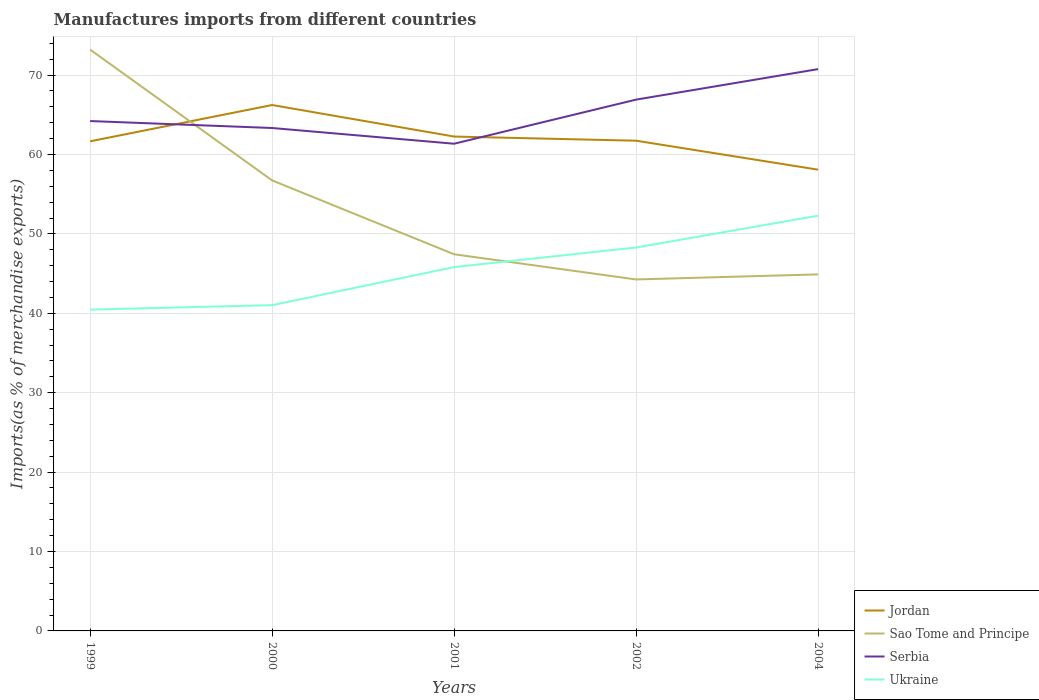How many different coloured lines are there?
Your response must be concise. 4. Does the line corresponding to Ukraine intersect with the line corresponding to Sao Tome and Principe?
Ensure brevity in your answer.  Yes. Across all years, what is the maximum percentage of imports to different countries in Jordan?
Make the answer very short. 58.09. What is the total percentage of imports to different countries in Sao Tome and Principe in the graph?
Provide a succinct answer. 11.83. What is the difference between the highest and the second highest percentage of imports to different countries in Sao Tome and Principe?
Ensure brevity in your answer.  28.95. How many lines are there?
Make the answer very short. 4. How many years are there in the graph?
Ensure brevity in your answer.  5. Does the graph contain any zero values?
Offer a terse response. No. Where does the legend appear in the graph?
Keep it short and to the point. Bottom right. How many legend labels are there?
Give a very brief answer. 4. What is the title of the graph?
Offer a terse response. Manufactures imports from different countries. Does "Cayman Islands" appear as one of the legend labels in the graph?
Give a very brief answer. No. What is the label or title of the Y-axis?
Keep it short and to the point. Imports(as % of merchandise exports). What is the Imports(as % of merchandise exports) of Jordan in 1999?
Your answer should be compact. 61.66. What is the Imports(as % of merchandise exports) of Sao Tome and Principe in 1999?
Your answer should be very brief. 73.21. What is the Imports(as % of merchandise exports) of Serbia in 1999?
Ensure brevity in your answer.  64.21. What is the Imports(as % of merchandise exports) of Ukraine in 1999?
Your answer should be compact. 40.46. What is the Imports(as % of merchandise exports) of Jordan in 2000?
Provide a succinct answer. 66.23. What is the Imports(as % of merchandise exports) in Sao Tome and Principe in 2000?
Offer a very short reply. 56.74. What is the Imports(as % of merchandise exports) in Serbia in 2000?
Offer a terse response. 63.34. What is the Imports(as % of merchandise exports) in Ukraine in 2000?
Your answer should be compact. 41.03. What is the Imports(as % of merchandise exports) of Jordan in 2001?
Your answer should be compact. 62.26. What is the Imports(as % of merchandise exports) of Sao Tome and Principe in 2001?
Your answer should be compact. 47.44. What is the Imports(as % of merchandise exports) of Serbia in 2001?
Offer a very short reply. 61.36. What is the Imports(as % of merchandise exports) in Ukraine in 2001?
Your answer should be very brief. 45.82. What is the Imports(as % of merchandise exports) of Jordan in 2002?
Your answer should be very brief. 61.74. What is the Imports(as % of merchandise exports) in Sao Tome and Principe in 2002?
Offer a terse response. 44.26. What is the Imports(as % of merchandise exports) in Serbia in 2002?
Give a very brief answer. 66.91. What is the Imports(as % of merchandise exports) in Ukraine in 2002?
Give a very brief answer. 48.29. What is the Imports(as % of merchandise exports) in Jordan in 2004?
Offer a very short reply. 58.09. What is the Imports(as % of merchandise exports) in Sao Tome and Principe in 2004?
Offer a very short reply. 44.9. What is the Imports(as % of merchandise exports) of Serbia in 2004?
Provide a succinct answer. 70.75. What is the Imports(as % of merchandise exports) of Ukraine in 2004?
Your response must be concise. 52.3. Across all years, what is the maximum Imports(as % of merchandise exports) of Jordan?
Your answer should be very brief. 66.23. Across all years, what is the maximum Imports(as % of merchandise exports) in Sao Tome and Principe?
Give a very brief answer. 73.21. Across all years, what is the maximum Imports(as % of merchandise exports) in Serbia?
Ensure brevity in your answer.  70.75. Across all years, what is the maximum Imports(as % of merchandise exports) in Ukraine?
Your answer should be very brief. 52.3. Across all years, what is the minimum Imports(as % of merchandise exports) in Jordan?
Ensure brevity in your answer.  58.09. Across all years, what is the minimum Imports(as % of merchandise exports) in Sao Tome and Principe?
Your response must be concise. 44.26. Across all years, what is the minimum Imports(as % of merchandise exports) in Serbia?
Provide a short and direct response. 61.36. Across all years, what is the minimum Imports(as % of merchandise exports) in Ukraine?
Provide a short and direct response. 40.46. What is the total Imports(as % of merchandise exports) of Jordan in the graph?
Your answer should be very brief. 309.98. What is the total Imports(as % of merchandise exports) of Sao Tome and Principe in the graph?
Offer a terse response. 266.55. What is the total Imports(as % of merchandise exports) of Serbia in the graph?
Your response must be concise. 326.57. What is the total Imports(as % of merchandise exports) of Ukraine in the graph?
Provide a succinct answer. 227.9. What is the difference between the Imports(as % of merchandise exports) in Jordan in 1999 and that in 2000?
Provide a short and direct response. -4.57. What is the difference between the Imports(as % of merchandise exports) in Sao Tome and Principe in 1999 and that in 2000?
Your answer should be compact. 16.48. What is the difference between the Imports(as % of merchandise exports) of Serbia in 1999 and that in 2000?
Give a very brief answer. 0.88. What is the difference between the Imports(as % of merchandise exports) in Ukraine in 1999 and that in 2000?
Offer a terse response. -0.56. What is the difference between the Imports(as % of merchandise exports) of Jordan in 1999 and that in 2001?
Offer a terse response. -0.6. What is the difference between the Imports(as % of merchandise exports) of Sao Tome and Principe in 1999 and that in 2001?
Keep it short and to the point. 25.78. What is the difference between the Imports(as % of merchandise exports) of Serbia in 1999 and that in 2001?
Provide a short and direct response. 2.85. What is the difference between the Imports(as % of merchandise exports) of Ukraine in 1999 and that in 2001?
Your answer should be compact. -5.36. What is the difference between the Imports(as % of merchandise exports) of Jordan in 1999 and that in 2002?
Make the answer very short. -0.08. What is the difference between the Imports(as % of merchandise exports) of Sao Tome and Principe in 1999 and that in 2002?
Offer a very short reply. 28.95. What is the difference between the Imports(as % of merchandise exports) of Serbia in 1999 and that in 2002?
Your answer should be compact. -2.7. What is the difference between the Imports(as % of merchandise exports) of Ukraine in 1999 and that in 2002?
Your answer should be very brief. -7.82. What is the difference between the Imports(as % of merchandise exports) in Jordan in 1999 and that in 2004?
Offer a very short reply. 3.57. What is the difference between the Imports(as % of merchandise exports) of Sao Tome and Principe in 1999 and that in 2004?
Your response must be concise. 28.31. What is the difference between the Imports(as % of merchandise exports) of Serbia in 1999 and that in 2004?
Give a very brief answer. -6.54. What is the difference between the Imports(as % of merchandise exports) in Ukraine in 1999 and that in 2004?
Offer a terse response. -11.83. What is the difference between the Imports(as % of merchandise exports) in Jordan in 2000 and that in 2001?
Your response must be concise. 3.97. What is the difference between the Imports(as % of merchandise exports) in Sao Tome and Principe in 2000 and that in 2001?
Keep it short and to the point. 9.3. What is the difference between the Imports(as % of merchandise exports) in Serbia in 2000 and that in 2001?
Provide a succinct answer. 1.98. What is the difference between the Imports(as % of merchandise exports) of Ukraine in 2000 and that in 2001?
Give a very brief answer. -4.8. What is the difference between the Imports(as % of merchandise exports) of Jordan in 2000 and that in 2002?
Your answer should be compact. 4.49. What is the difference between the Imports(as % of merchandise exports) in Sao Tome and Principe in 2000 and that in 2002?
Make the answer very short. 12.47. What is the difference between the Imports(as % of merchandise exports) of Serbia in 2000 and that in 2002?
Offer a very short reply. -3.58. What is the difference between the Imports(as % of merchandise exports) of Ukraine in 2000 and that in 2002?
Provide a short and direct response. -7.26. What is the difference between the Imports(as % of merchandise exports) in Jordan in 2000 and that in 2004?
Offer a terse response. 8.14. What is the difference between the Imports(as % of merchandise exports) in Sao Tome and Principe in 2000 and that in 2004?
Keep it short and to the point. 11.83. What is the difference between the Imports(as % of merchandise exports) in Serbia in 2000 and that in 2004?
Your response must be concise. -7.42. What is the difference between the Imports(as % of merchandise exports) of Ukraine in 2000 and that in 2004?
Ensure brevity in your answer.  -11.27. What is the difference between the Imports(as % of merchandise exports) of Jordan in 2001 and that in 2002?
Your response must be concise. 0.52. What is the difference between the Imports(as % of merchandise exports) in Sao Tome and Principe in 2001 and that in 2002?
Offer a very short reply. 3.17. What is the difference between the Imports(as % of merchandise exports) of Serbia in 2001 and that in 2002?
Make the answer very short. -5.55. What is the difference between the Imports(as % of merchandise exports) in Ukraine in 2001 and that in 2002?
Your response must be concise. -2.47. What is the difference between the Imports(as % of merchandise exports) in Jordan in 2001 and that in 2004?
Keep it short and to the point. 4.17. What is the difference between the Imports(as % of merchandise exports) in Sao Tome and Principe in 2001 and that in 2004?
Offer a very short reply. 2.53. What is the difference between the Imports(as % of merchandise exports) in Serbia in 2001 and that in 2004?
Keep it short and to the point. -9.4. What is the difference between the Imports(as % of merchandise exports) in Ukraine in 2001 and that in 2004?
Your answer should be very brief. -6.47. What is the difference between the Imports(as % of merchandise exports) of Jordan in 2002 and that in 2004?
Keep it short and to the point. 3.65. What is the difference between the Imports(as % of merchandise exports) of Sao Tome and Principe in 2002 and that in 2004?
Offer a terse response. -0.64. What is the difference between the Imports(as % of merchandise exports) in Serbia in 2002 and that in 2004?
Your response must be concise. -3.84. What is the difference between the Imports(as % of merchandise exports) of Ukraine in 2002 and that in 2004?
Give a very brief answer. -4.01. What is the difference between the Imports(as % of merchandise exports) of Jordan in 1999 and the Imports(as % of merchandise exports) of Sao Tome and Principe in 2000?
Ensure brevity in your answer.  4.92. What is the difference between the Imports(as % of merchandise exports) of Jordan in 1999 and the Imports(as % of merchandise exports) of Serbia in 2000?
Keep it short and to the point. -1.68. What is the difference between the Imports(as % of merchandise exports) in Jordan in 1999 and the Imports(as % of merchandise exports) in Ukraine in 2000?
Provide a short and direct response. 20.63. What is the difference between the Imports(as % of merchandise exports) of Sao Tome and Principe in 1999 and the Imports(as % of merchandise exports) of Serbia in 2000?
Your answer should be compact. 9.88. What is the difference between the Imports(as % of merchandise exports) in Sao Tome and Principe in 1999 and the Imports(as % of merchandise exports) in Ukraine in 2000?
Offer a terse response. 32.19. What is the difference between the Imports(as % of merchandise exports) of Serbia in 1999 and the Imports(as % of merchandise exports) of Ukraine in 2000?
Provide a short and direct response. 23.18. What is the difference between the Imports(as % of merchandise exports) of Jordan in 1999 and the Imports(as % of merchandise exports) of Sao Tome and Principe in 2001?
Your response must be concise. 14.23. What is the difference between the Imports(as % of merchandise exports) in Jordan in 1999 and the Imports(as % of merchandise exports) in Serbia in 2001?
Provide a short and direct response. 0.3. What is the difference between the Imports(as % of merchandise exports) in Jordan in 1999 and the Imports(as % of merchandise exports) in Ukraine in 2001?
Your answer should be compact. 15.84. What is the difference between the Imports(as % of merchandise exports) in Sao Tome and Principe in 1999 and the Imports(as % of merchandise exports) in Serbia in 2001?
Make the answer very short. 11.86. What is the difference between the Imports(as % of merchandise exports) of Sao Tome and Principe in 1999 and the Imports(as % of merchandise exports) of Ukraine in 2001?
Offer a very short reply. 27.39. What is the difference between the Imports(as % of merchandise exports) in Serbia in 1999 and the Imports(as % of merchandise exports) in Ukraine in 2001?
Your answer should be very brief. 18.39. What is the difference between the Imports(as % of merchandise exports) of Jordan in 1999 and the Imports(as % of merchandise exports) of Sao Tome and Principe in 2002?
Offer a terse response. 17.4. What is the difference between the Imports(as % of merchandise exports) of Jordan in 1999 and the Imports(as % of merchandise exports) of Serbia in 2002?
Your response must be concise. -5.25. What is the difference between the Imports(as % of merchandise exports) in Jordan in 1999 and the Imports(as % of merchandise exports) in Ukraine in 2002?
Keep it short and to the point. 13.37. What is the difference between the Imports(as % of merchandise exports) in Sao Tome and Principe in 1999 and the Imports(as % of merchandise exports) in Serbia in 2002?
Make the answer very short. 6.3. What is the difference between the Imports(as % of merchandise exports) of Sao Tome and Principe in 1999 and the Imports(as % of merchandise exports) of Ukraine in 2002?
Your response must be concise. 24.93. What is the difference between the Imports(as % of merchandise exports) in Serbia in 1999 and the Imports(as % of merchandise exports) in Ukraine in 2002?
Your answer should be very brief. 15.92. What is the difference between the Imports(as % of merchandise exports) in Jordan in 1999 and the Imports(as % of merchandise exports) in Sao Tome and Principe in 2004?
Keep it short and to the point. 16.76. What is the difference between the Imports(as % of merchandise exports) of Jordan in 1999 and the Imports(as % of merchandise exports) of Serbia in 2004?
Make the answer very short. -9.09. What is the difference between the Imports(as % of merchandise exports) in Jordan in 1999 and the Imports(as % of merchandise exports) in Ukraine in 2004?
Offer a very short reply. 9.36. What is the difference between the Imports(as % of merchandise exports) of Sao Tome and Principe in 1999 and the Imports(as % of merchandise exports) of Serbia in 2004?
Keep it short and to the point. 2.46. What is the difference between the Imports(as % of merchandise exports) in Sao Tome and Principe in 1999 and the Imports(as % of merchandise exports) in Ukraine in 2004?
Ensure brevity in your answer.  20.92. What is the difference between the Imports(as % of merchandise exports) in Serbia in 1999 and the Imports(as % of merchandise exports) in Ukraine in 2004?
Offer a very short reply. 11.92. What is the difference between the Imports(as % of merchandise exports) of Jordan in 2000 and the Imports(as % of merchandise exports) of Sao Tome and Principe in 2001?
Keep it short and to the point. 18.8. What is the difference between the Imports(as % of merchandise exports) in Jordan in 2000 and the Imports(as % of merchandise exports) in Serbia in 2001?
Ensure brevity in your answer.  4.87. What is the difference between the Imports(as % of merchandise exports) of Jordan in 2000 and the Imports(as % of merchandise exports) of Ukraine in 2001?
Ensure brevity in your answer.  20.41. What is the difference between the Imports(as % of merchandise exports) of Sao Tome and Principe in 2000 and the Imports(as % of merchandise exports) of Serbia in 2001?
Provide a succinct answer. -4.62. What is the difference between the Imports(as % of merchandise exports) of Sao Tome and Principe in 2000 and the Imports(as % of merchandise exports) of Ukraine in 2001?
Make the answer very short. 10.91. What is the difference between the Imports(as % of merchandise exports) of Serbia in 2000 and the Imports(as % of merchandise exports) of Ukraine in 2001?
Ensure brevity in your answer.  17.51. What is the difference between the Imports(as % of merchandise exports) of Jordan in 2000 and the Imports(as % of merchandise exports) of Sao Tome and Principe in 2002?
Your response must be concise. 21.97. What is the difference between the Imports(as % of merchandise exports) in Jordan in 2000 and the Imports(as % of merchandise exports) in Serbia in 2002?
Give a very brief answer. -0.68. What is the difference between the Imports(as % of merchandise exports) in Jordan in 2000 and the Imports(as % of merchandise exports) in Ukraine in 2002?
Give a very brief answer. 17.94. What is the difference between the Imports(as % of merchandise exports) of Sao Tome and Principe in 2000 and the Imports(as % of merchandise exports) of Serbia in 2002?
Offer a very short reply. -10.18. What is the difference between the Imports(as % of merchandise exports) of Sao Tome and Principe in 2000 and the Imports(as % of merchandise exports) of Ukraine in 2002?
Give a very brief answer. 8.45. What is the difference between the Imports(as % of merchandise exports) of Serbia in 2000 and the Imports(as % of merchandise exports) of Ukraine in 2002?
Your response must be concise. 15.05. What is the difference between the Imports(as % of merchandise exports) of Jordan in 2000 and the Imports(as % of merchandise exports) of Sao Tome and Principe in 2004?
Give a very brief answer. 21.33. What is the difference between the Imports(as % of merchandise exports) of Jordan in 2000 and the Imports(as % of merchandise exports) of Serbia in 2004?
Provide a succinct answer. -4.52. What is the difference between the Imports(as % of merchandise exports) of Jordan in 2000 and the Imports(as % of merchandise exports) of Ukraine in 2004?
Provide a short and direct response. 13.94. What is the difference between the Imports(as % of merchandise exports) in Sao Tome and Principe in 2000 and the Imports(as % of merchandise exports) in Serbia in 2004?
Provide a short and direct response. -14.02. What is the difference between the Imports(as % of merchandise exports) in Sao Tome and Principe in 2000 and the Imports(as % of merchandise exports) in Ukraine in 2004?
Offer a very short reply. 4.44. What is the difference between the Imports(as % of merchandise exports) in Serbia in 2000 and the Imports(as % of merchandise exports) in Ukraine in 2004?
Provide a succinct answer. 11.04. What is the difference between the Imports(as % of merchandise exports) of Jordan in 2001 and the Imports(as % of merchandise exports) of Sao Tome and Principe in 2002?
Ensure brevity in your answer.  18. What is the difference between the Imports(as % of merchandise exports) of Jordan in 2001 and the Imports(as % of merchandise exports) of Serbia in 2002?
Give a very brief answer. -4.65. What is the difference between the Imports(as % of merchandise exports) in Jordan in 2001 and the Imports(as % of merchandise exports) in Ukraine in 2002?
Your response must be concise. 13.97. What is the difference between the Imports(as % of merchandise exports) in Sao Tome and Principe in 2001 and the Imports(as % of merchandise exports) in Serbia in 2002?
Provide a succinct answer. -19.48. What is the difference between the Imports(as % of merchandise exports) of Sao Tome and Principe in 2001 and the Imports(as % of merchandise exports) of Ukraine in 2002?
Ensure brevity in your answer.  -0.85. What is the difference between the Imports(as % of merchandise exports) in Serbia in 2001 and the Imports(as % of merchandise exports) in Ukraine in 2002?
Your answer should be very brief. 13.07. What is the difference between the Imports(as % of merchandise exports) in Jordan in 2001 and the Imports(as % of merchandise exports) in Sao Tome and Principe in 2004?
Give a very brief answer. 17.36. What is the difference between the Imports(as % of merchandise exports) of Jordan in 2001 and the Imports(as % of merchandise exports) of Serbia in 2004?
Give a very brief answer. -8.49. What is the difference between the Imports(as % of merchandise exports) of Jordan in 2001 and the Imports(as % of merchandise exports) of Ukraine in 2004?
Provide a short and direct response. 9.97. What is the difference between the Imports(as % of merchandise exports) in Sao Tome and Principe in 2001 and the Imports(as % of merchandise exports) in Serbia in 2004?
Your answer should be very brief. -23.32. What is the difference between the Imports(as % of merchandise exports) in Sao Tome and Principe in 2001 and the Imports(as % of merchandise exports) in Ukraine in 2004?
Your response must be concise. -4.86. What is the difference between the Imports(as % of merchandise exports) of Serbia in 2001 and the Imports(as % of merchandise exports) of Ukraine in 2004?
Offer a terse response. 9.06. What is the difference between the Imports(as % of merchandise exports) in Jordan in 2002 and the Imports(as % of merchandise exports) in Sao Tome and Principe in 2004?
Make the answer very short. 16.84. What is the difference between the Imports(as % of merchandise exports) in Jordan in 2002 and the Imports(as % of merchandise exports) in Serbia in 2004?
Provide a short and direct response. -9.02. What is the difference between the Imports(as % of merchandise exports) in Jordan in 2002 and the Imports(as % of merchandise exports) in Ukraine in 2004?
Your answer should be compact. 9.44. What is the difference between the Imports(as % of merchandise exports) in Sao Tome and Principe in 2002 and the Imports(as % of merchandise exports) in Serbia in 2004?
Make the answer very short. -26.49. What is the difference between the Imports(as % of merchandise exports) of Sao Tome and Principe in 2002 and the Imports(as % of merchandise exports) of Ukraine in 2004?
Your answer should be compact. -8.03. What is the difference between the Imports(as % of merchandise exports) of Serbia in 2002 and the Imports(as % of merchandise exports) of Ukraine in 2004?
Your answer should be very brief. 14.62. What is the average Imports(as % of merchandise exports) in Jordan per year?
Your answer should be compact. 62. What is the average Imports(as % of merchandise exports) of Sao Tome and Principe per year?
Your response must be concise. 53.31. What is the average Imports(as % of merchandise exports) of Serbia per year?
Offer a very short reply. 65.31. What is the average Imports(as % of merchandise exports) of Ukraine per year?
Your answer should be very brief. 45.58. In the year 1999, what is the difference between the Imports(as % of merchandise exports) in Jordan and Imports(as % of merchandise exports) in Sao Tome and Principe?
Keep it short and to the point. -11.55. In the year 1999, what is the difference between the Imports(as % of merchandise exports) in Jordan and Imports(as % of merchandise exports) in Serbia?
Provide a short and direct response. -2.55. In the year 1999, what is the difference between the Imports(as % of merchandise exports) in Jordan and Imports(as % of merchandise exports) in Ukraine?
Give a very brief answer. 21.2. In the year 1999, what is the difference between the Imports(as % of merchandise exports) in Sao Tome and Principe and Imports(as % of merchandise exports) in Serbia?
Give a very brief answer. 9. In the year 1999, what is the difference between the Imports(as % of merchandise exports) in Sao Tome and Principe and Imports(as % of merchandise exports) in Ukraine?
Give a very brief answer. 32.75. In the year 1999, what is the difference between the Imports(as % of merchandise exports) in Serbia and Imports(as % of merchandise exports) in Ukraine?
Your response must be concise. 23.75. In the year 2000, what is the difference between the Imports(as % of merchandise exports) of Jordan and Imports(as % of merchandise exports) of Sao Tome and Principe?
Provide a succinct answer. 9.5. In the year 2000, what is the difference between the Imports(as % of merchandise exports) in Jordan and Imports(as % of merchandise exports) in Serbia?
Your response must be concise. 2.9. In the year 2000, what is the difference between the Imports(as % of merchandise exports) of Jordan and Imports(as % of merchandise exports) of Ukraine?
Give a very brief answer. 25.2. In the year 2000, what is the difference between the Imports(as % of merchandise exports) in Sao Tome and Principe and Imports(as % of merchandise exports) in Serbia?
Provide a succinct answer. -6.6. In the year 2000, what is the difference between the Imports(as % of merchandise exports) of Sao Tome and Principe and Imports(as % of merchandise exports) of Ukraine?
Ensure brevity in your answer.  15.71. In the year 2000, what is the difference between the Imports(as % of merchandise exports) of Serbia and Imports(as % of merchandise exports) of Ukraine?
Your answer should be compact. 22.31. In the year 2001, what is the difference between the Imports(as % of merchandise exports) in Jordan and Imports(as % of merchandise exports) in Sao Tome and Principe?
Your answer should be compact. 14.83. In the year 2001, what is the difference between the Imports(as % of merchandise exports) of Jordan and Imports(as % of merchandise exports) of Serbia?
Provide a short and direct response. 0.9. In the year 2001, what is the difference between the Imports(as % of merchandise exports) of Jordan and Imports(as % of merchandise exports) of Ukraine?
Make the answer very short. 16.44. In the year 2001, what is the difference between the Imports(as % of merchandise exports) of Sao Tome and Principe and Imports(as % of merchandise exports) of Serbia?
Offer a very short reply. -13.92. In the year 2001, what is the difference between the Imports(as % of merchandise exports) of Sao Tome and Principe and Imports(as % of merchandise exports) of Ukraine?
Your response must be concise. 1.61. In the year 2001, what is the difference between the Imports(as % of merchandise exports) in Serbia and Imports(as % of merchandise exports) in Ukraine?
Give a very brief answer. 15.54. In the year 2002, what is the difference between the Imports(as % of merchandise exports) in Jordan and Imports(as % of merchandise exports) in Sao Tome and Principe?
Offer a very short reply. 17.48. In the year 2002, what is the difference between the Imports(as % of merchandise exports) in Jordan and Imports(as % of merchandise exports) in Serbia?
Offer a terse response. -5.17. In the year 2002, what is the difference between the Imports(as % of merchandise exports) of Jordan and Imports(as % of merchandise exports) of Ukraine?
Your answer should be compact. 13.45. In the year 2002, what is the difference between the Imports(as % of merchandise exports) of Sao Tome and Principe and Imports(as % of merchandise exports) of Serbia?
Your response must be concise. -22.65. In the year 2002, what is the difference between the Imports(as % of merchandise exports) in Sao Tome and Principe and Imports(as % of merchandise exports) in Ukraine?
Your answer should be compact. -4.03. In the year 2002, what is the difference between the Imports(as % of merchandise exports) in Serbia and Imports(as % of merchandise exports) in Ukraine?
Offer a terse response. 18.62. In the year 2004, what is the difference between the Imports(as % of merchandise exports) of Jordan and Imports(as % of merchandise exports) of Sao Tome and Principe?
Provide a succinct answer. 13.19. In the year 2004, what is the difference between the Imports(as % of merchandise exports) in Jordan and Imports(as % of merchandise exports) in Serbia?
Give a very brief answer. -12.67. In the year 2004, what is the difference between the Imports(as % of merchandise exports) of Jordan and Imports(as % of merchandise exports) of Ukraine?
Give a very brief answer. 5.79. In the year 2004, what is the difference between the Imports(as % of merchandise exports) in Sao Tome and Principe and Imports(as % of merchandise exports) in Serbia?
Give a very brief answer. -25.85. In the year 2004, what is the difference between the Imports(as % of merchandise exports) in Sao Tome and Principe and Imports(as % of merchandise exports) in Ukraine?
Give a very brief answer. -7.39. In the year 2004, what is the difference between the Imports(as % of merchandise exports) in Serbia and Imports(as % of merchandise exports) in Ukraine?
Provide a succinct answer. 18.46. What is the ratio of the Imports(as % of merchandise exports) in Jordan in 1999 to that in 2000?
Your response must be concise. 0.93. What is the ratio of the Imports(as % of merchandise exports) of Sao Tome and Principe in 1999 to that in 2000?
Provide a short and direct response. 1.29. What is the ratio of the Imports(as % of merchandise exports) of Serbia in 1999 to that in 2000?
Offer a very short reply. 1.01. What is the ratio of the Imports(as % of merchandise exports) of Ukraine in 1999 to that in 2000?
Ensure brevity in your answer.  0.99. What is the ratio of the Imports(as % of merchandise exports) of Jordan in 1999 to that in 2001?
Provide a short and direct response. 0.99. What is the ratio of the Imports(as % of merchandise exports) of Sao Tome and Principe in 1999 to that in 2001?
Offer a very short reply. 1.54. What is the ratio of the Imports(as % of merchandise exports) of Serbia in 1999 to that in 2001?
Give a very brief answer. 1.05. What is the ratio of the Imports(as % of merchandise exports) in Ukraine in 1999 to that in 2001?
Your answer should be very brief. 0.88. What is the ratio of the Imports(as % of merchandise exports) of Sao Tome and Principe in 1999 to that in 2002?
Give a very brief answer. 1.65. What is the ratio of the Imports(as % of merchandise exports) in Serbia in 1999 to that in 2002?
Keep it short and to the point. 0.96. What is the ratio of the Imports(as % of merchandise exports) in Ukraine in 1999 to that in 2002?
Your answer should be compact. 0.84. What is the ratio of the Imports(as % of merchandise exports) of Jordan in 1999 to that in 2004?
Offer a terse response. 1.06. What is the ratio of the Imports(as % of merchandise exports) of Sao Tome and Principe in 1999 to that in 2004?
Offer a very short reply. 1.63. What is the ratio of the Imports(as % of merchandise exports) of Serbia in 1999 to that in 2004?
Your response must be concise. 0.91. What is the ratio of the Imports(as % of merchandise exports) of Ukraine in 1999 to that in 2004?
Keep it short and to the point. 0.77. What is the ratio of the Imports(as % of merchandise exports) in Jordan in 2000 to that in 2001?
Provide a succinct answer. 1.06. What is the ratio of the Imports(as % of merchandise exports) of Sao Tome and Principe in 2000 to that in 2001?
Offer a terse response. 1.2. What is the ratio of the Imports(as % of merchandise exports) in Serbia in 2000 to that in 2001?
Provide a succinct answer. 1.03. What is the ratio of the Imports(as % of merchandise exports) of Ukraine in 2000 to that in 2001?
Offer a terse response. 0.9. What is the ratio of the Imports(as % of merchandise exports) in Jordan in 2000 to that in 2002?
Keep it short and to the point. 1.07. What is the ratio of the Imports(as % of merchandise exports) of Sao Tome and Principe in 2000 to that in 2002?
Provide a succinct answer. 1.28. What is the ratio of the Imports(as % of merchandise exports) in Serbia in 2000 to that in 2002?
Your answer should be compact. 0.95. What is the ratio of the Imports(as % of merchandise exports) of Ukraine in 2000 to that in 2002?
Keep it short and to the point. 0.85. What is the ratio of the Imports(as % of merchandise exports) of Jordan in 2000 to that in 2004?
Keep it short and to the point. 1.14. What is the ratio of the Imports(as % of merchandise exports) in Sao Tome and Principe in 2000 to that in 2004?
Offer a very short reply. 1.26. What is the ratio of the Imports(as % of merchandise exports) in Serbia in 2000 to that in 2004?
Ensure brevity in your answer.  0.9. What is the ratio of the Imports(as % of merchandise exports) of Ukraine in 2000 to that in 2004?
Your answer should be compact. 0.78. What is the ratio of the Imports(as % of merchandise exports) in Jordan in 2001 to that in 2002?
Your answer should be very brief. 1.01. What is the ratio of the Imports(as % of merchandise exports) of Sao Tome and Principe in 2001 to that in 2002?
Your answer should be compact. 1.07. What is the ratio of the Imports(as % of merchandise exports) in Serbia in 2001 to that in 2002?
Ensure brevity in your answer.  0.92. What is the ratio of the Imports(as % of merchandise exports) in Ukraine in 2001 to that in 2002?
Offer a terse response. 0.95. What is the ratio of the Imports(as % of merchandise exports) in Jordan in 2001 to that in 2004?
Your answer should be compact. 1.07. What is the ratio of the Imports(as % of merchandise exports) of Sao Tome and Principe in 2001 to that in 2004?
Ensure brevity in your answer.  1.06. What is the ratio of the Imports(as % of merchandise exports) of Serbia in 2001 to that in 2004?
Your answer should be compact. 0.87. What is the ratio of the Imports(as % of merchandise exports) in Ukraine in 2001 to that in 2004?
Ensure brevity in your answer.  0.88. What is the ratio of the Imports(as % of merchandise exports) of Jordan in 2002 to that in 2004?
Provide a short and direct response. 1.06. What is the ratio of the Imports(as % of merchandise exports) of Sao Tome and Principe in 2002 to that in 2004?
Your answer should be compact. 0.99. What is the ratio of the Imports(as % of merchandise exports) of Serbia in 2002 to that in 2004?
Provide a short and direct response. 0.95. What is the ratio of the Imports(as % of merchandise exports) in Ukraine in 2002 to that in 2004?
Ensure brevity in your answer.  0.92. What is the difference between the highest and the second highest Imports(as % of merchandise exports) in Jordan?
Ensure brevity in your answer.  3.97. What is the difference between the highest and the second highest Imports(as % of merchandise exports) of Sao Tome and Principe?
Offer a terse response. 16.48. What is the difference between the highest and the second highest Imports(as % of merchandise exports) of Serbia?
Your response must be concise. 3.84. What is the difference between the highest and the second highest Imports(as % of merchandise exports) in Ukraine?
Make the answer very short. 4.01. What is the difference between the highest and the lowest Imports(as % of merchandise exports) in Jordan?
Offer a terse response. 8.14. What is the difference between the highest and the lowest Imports(as % of merchandise exports) in Sao Tome and Principe?
Your answer should be compact. 28.95. What is the difference between the highest and the lowest Imports(as % of merchandise exports) of Serbia?
Provide a succinct answer. 9.4. What is the difference between the highest and the lowest Imports(as % of merchandise exports) in Ukraine?
Your response must be concise. 11.83. 